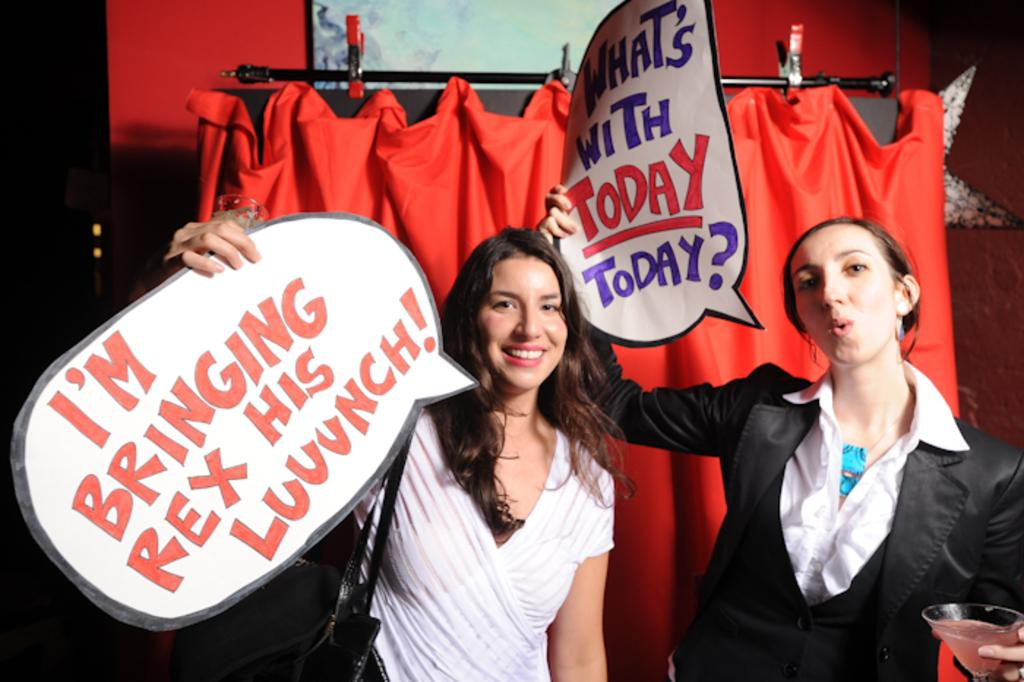What can be seen in the image? There are women standing in the image. What are the women holding in their hands? The women are holding papers with text in their hands. What can be seen in the background of the image? There is a curtain, a decorative item, and a wall hanging on the wall in the background of the image. What type of surprise can be seen on top of the decorative item in the image? There is no surprise visible on top of the decorative item in the image. 